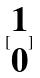<formula> <loc_0><loc_0><loc_500><loc_500>[ \begin{matrix} 1 \\ 0 \end{matrix} ]</formula> 